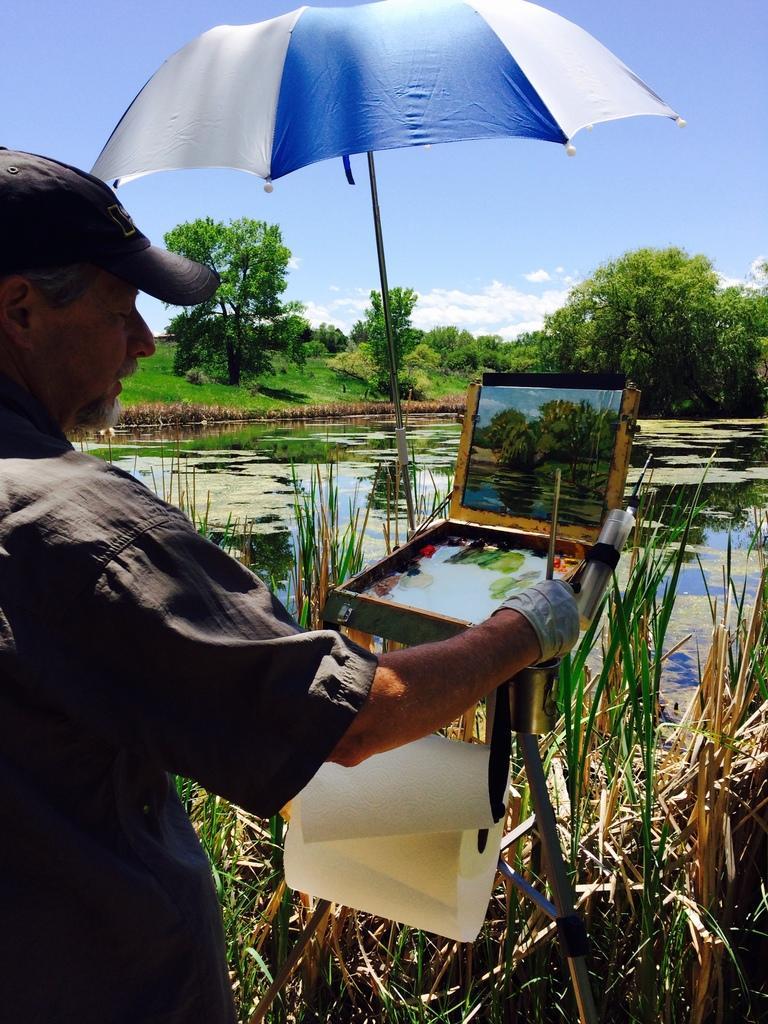How would you summarize this image in a sentence or two? In this picture we can see a man standing and holding a painting brush, we can see painting stand, at the bottom there is grass, we can see water in the middle, in the background there are some trees and the sky, there is an umbrella at the top of the picture, we can see charts here. 